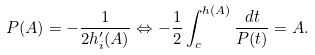Convert formula to latex. <formula><loc_0><loc_0><loc_500><loc_500>P ( A ) = - \frac { 1 } { 2 h _ { i } ^ { \prime } ( A ) } \Leftrightarrow - \frac { 1 } { 2 } \int ^ { h ( A ) } _ { c } \frac { d t } { P ( t ) } = A .</formula> 